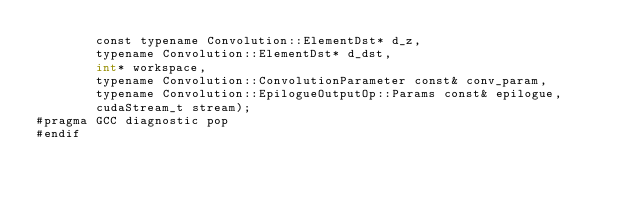<code> <loc_0><loc_0><loc_500><loc_500><_Cuda_>        const typename Convolution::ElementDst* d_z, 
        typename Convolution::ElementDst* d_dst, 
        int* workspace, 
        typename Convolution::ConvolutionParameter const& conv_param, 
        typename Convolution::EpilogueOutputOp::Params const& epilogue, 
        cudaStream_t stream);
#pragma GCC diagnostic pop
#endif
</code> 